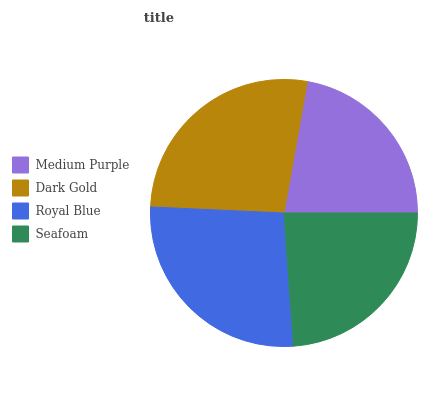Is Medium Purple the minimum?
Answer yes or no. Yes. Is Dark Gold the maximum?
Answer yes or no. Yes. Is Royal Blue the minimum?
Answer yes or no. No. Is Royal Blue the maximum?
Answer yes or no. No. Is Dark Gold greater than Royal Blue?
Answer yes or no. Yes. Is Royal Blue less than Dark Gold?
Answer yes or no. Yes. Is Royal Blue greater than Dark Gold?
Answer yes or no. No. Is Dark Gold less than Royal Blue?
Answer yes or no. No. Is Royal Blue the high median?
Answer yes or no. Yes. Is Seafoam the low median?
Answer yes or no. Yes. Is Seafoam the high median?
Answer yes or no. No. Is Royal Blue the low median?
Answer yes or no. No. 